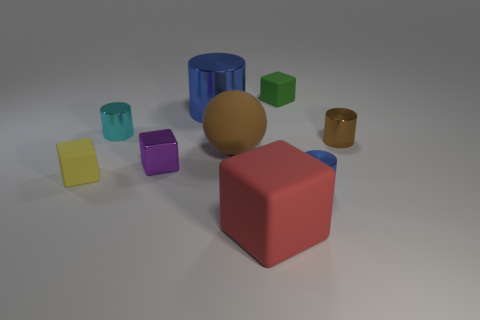Are there the same number of tiny green matte objects in front of the purple shiny block and small green matte objects behind the small green matte thing?
Keep it short and to the point. Yes. Is the color of the metallic cylinder that is in front of the small yellow rubber block the same as the large object that is behind the brown metal object?
Your answer should be compact. Yes. Is the number of tiny shiny cylinders left of the tiny green thing greater than the number of big shiny cylinders?
Provide a succinct answer. No. What is the material of the red object?
Offer a terse response. Rubber. What is the shape of the green thing that is made of the same material as the small yellow object?
Your response must be concise. Cube. How big is the blue cylinder that is in front of the large thing behind the cyan cylinder?
Provide a succinct answer. Small. There is a tiny cylinder on the left side of the green matte cube; what is its color?
Provide a short and direct response. Cyan. Is there a tiny cyan thing that has the same shape as the big blue thing?
Provide a short and direct response. Yes. Is the number of big blue things that are behind the tiny green object less than the number of tiny matte things on the right side of the big blue cylinder?
Your answer should be very brief. Yes. The big shiny object has what color?
Ensure brevity in your answer.  Blue. 